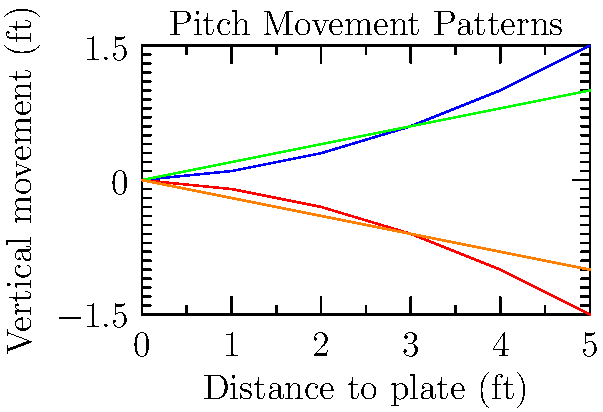Based on the graph showing the movement patterns of different pitch types, which pitch has the most dramatic downward break as it approaches the plate? To answer this question, we need to analyze the vertical movement patterns of each pitch type as shown in the graph:

1. Fastball (blue line): Shows a slight upward movement, ending at about 1.5 feet above the starting point.
2. Curveball (red line): Displays a significant downward break, ending at approximately 1.5 feet below the starting point.
3. Slider (green line): Exhibits a moderate upward movement, finishing around 1 foot above the starting point.
4. Changeup (orange line): Shows a moderate downward movement, ending about 1 foot below the starting point.

Comparing these patterns, we can see that the curveball (red line) has the most dramatic downward break. It starts at the same point as the other pitches but drops sharply as it approaches the plate, ending up with the lowest vertical position of all the pitches shown.

This dramatic downward movement is a key characteristic of curveballs, which are known for their sharp breaking action. As a former baseball player, you would recognize this movement as particularly challenging for batters to hit, especially when well-executed.
Answer: Curveball 